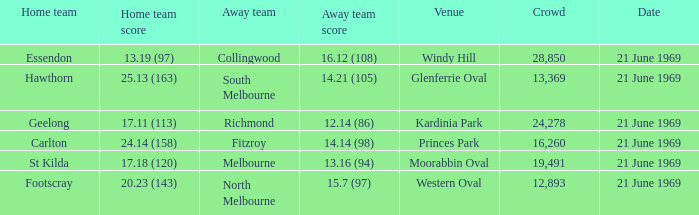When did an away team score 15.7 (97)? 21 June 1969. 